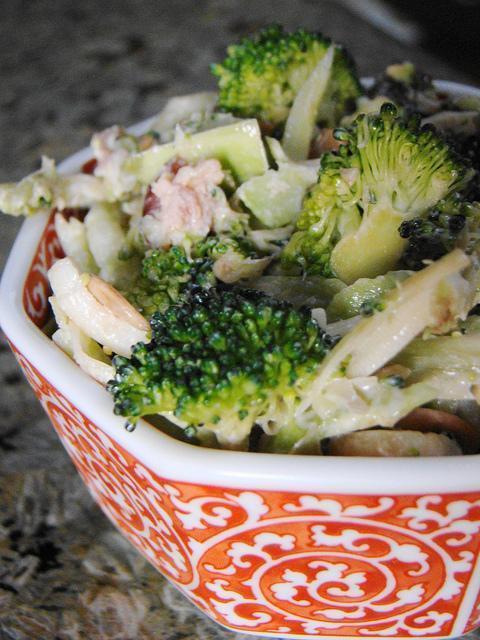How many broccolis are there?
Give a very brief answer. 5. 